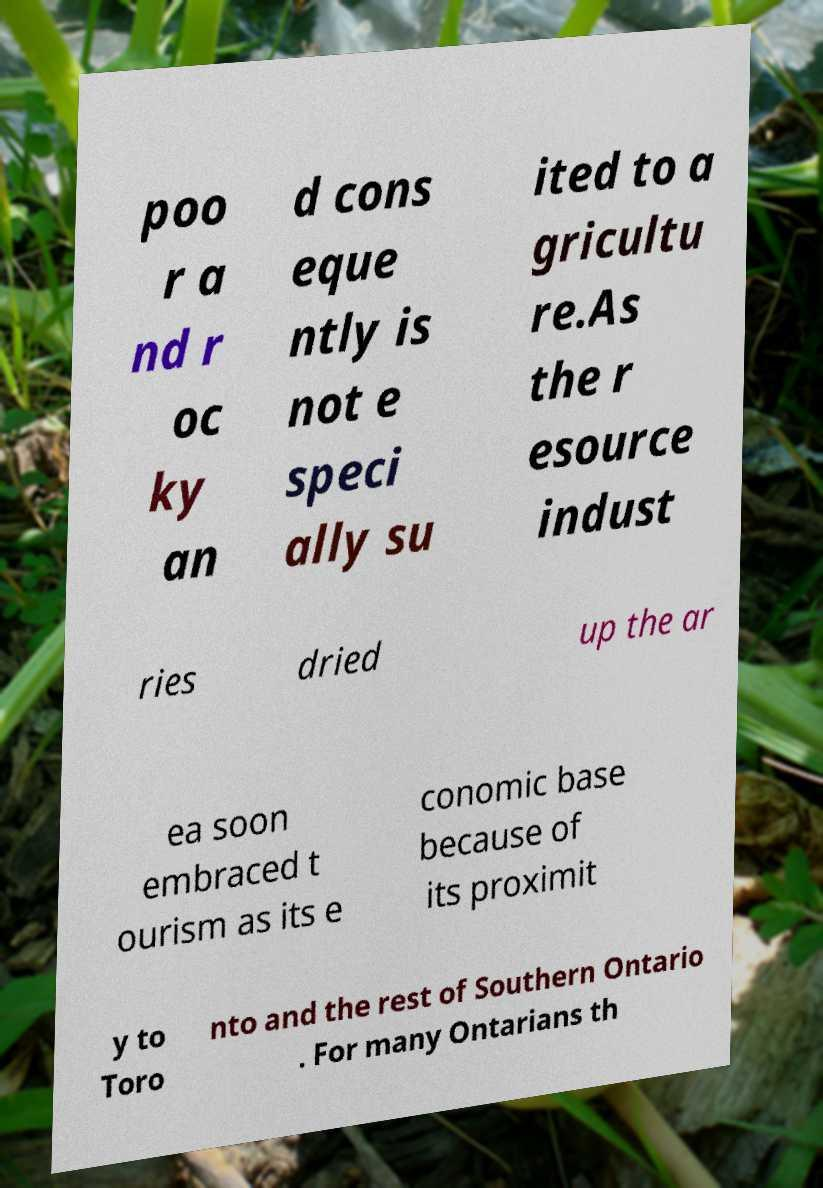I need the written content from this picture converted into text. Can you do that? poo r a nd r oc ky an d cons eque ntly is not e speci ally su ited to a gricultu re.As the r esource indust ries dried up the ar ea soon embraced t ourism as its e conomic base because of its proximit y to Toro nto and the rest of Southern Ontario . For many Ontarians th 